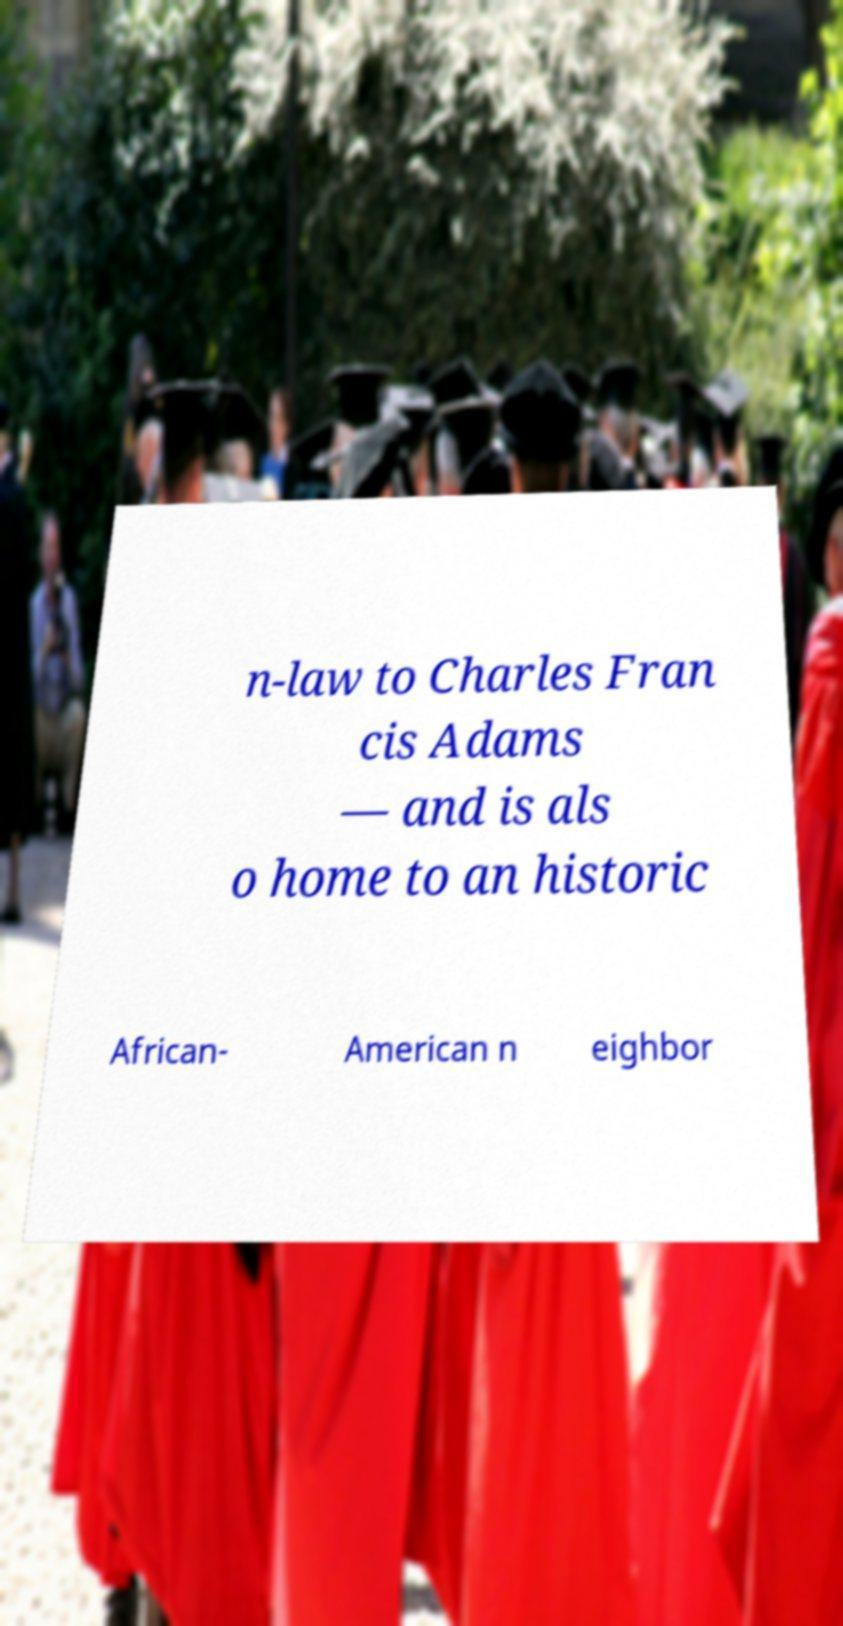What messages or text are displayed in this image? I need them in a readable, typed format. n-law to Charles Fran cis Adams — and is als o home to an historic African- American n eighbor 